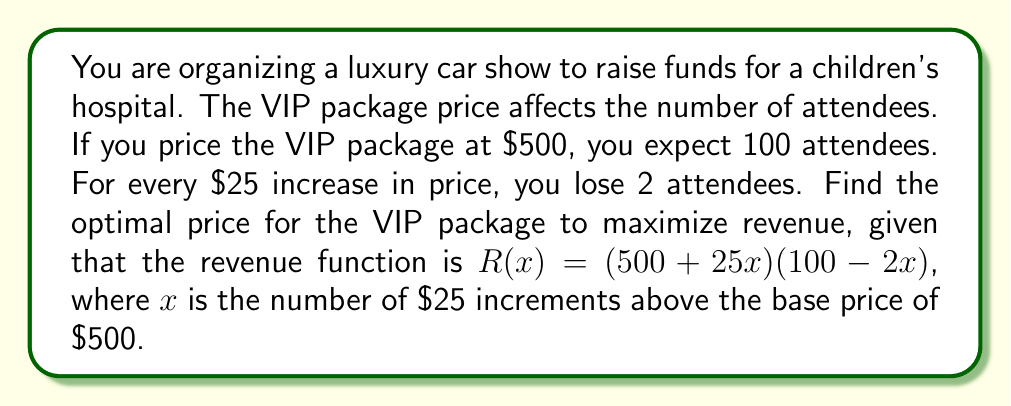Teach me how to tackle this problem. To find the optimal price, we need to maximize the revenue function. Let's approach this step-by-step:

1) First, let's expand the revenue function:
   $R(x) = (500 + 25x)(100 - 2x)$
   $R(x) = 50000 + 2500x - 1000x - 50x^2$
   $R(x) = 50000 + 1500x - 50x^2$

2) To find the maximum, we need to find where the derivative of $R(x)$ equals zero:
   $R'(x) = 1500 - 100x$

3) Set $R'(x) = 0$ and solve for $x$:
   $1500 - 100x = 0$
   $1500 = 100x$
   $x = 15$

4) To confirm this is a maximum, we can check that the second derivative is negative:
   $R''(x) = -100$, which is indeed negative.

5) Now that we know $x = 15$ maximizes revenue, let's calculate the optimal price:
   Optimal price = $500 + (25 * 15) = $875$

6) We can also calculate the maximum revenue:
   $R(15) = 50000 + 1500(15) - 50(15)^2 = 61250$

Therefore, the optimal price for the VIP package is $875, which would result in 70 attendees (100 - 2*15) and a maximum revenue of $61,250.
Answer: The optimal price for the VIP package is $875. 